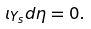Convert formula to latex. <formula><loc_0><loc_0><loc_500><loc_500>\iota _ { Y _ { s } } d \eta = 0 .</formula> 